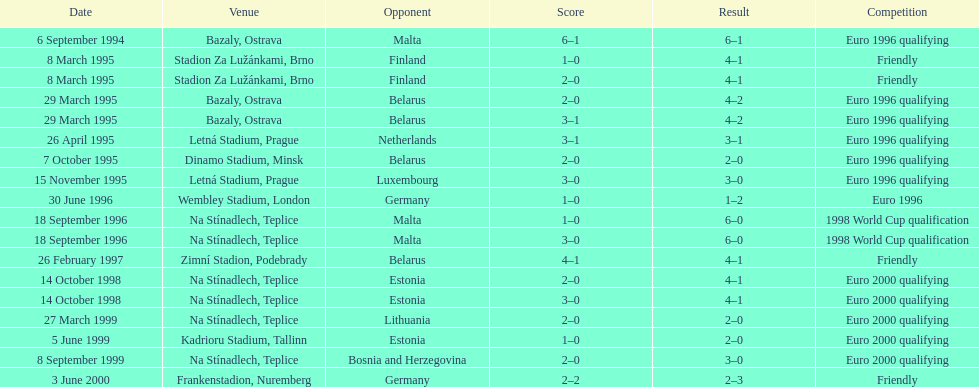What was the number of times czech republic played against germany? 2. 